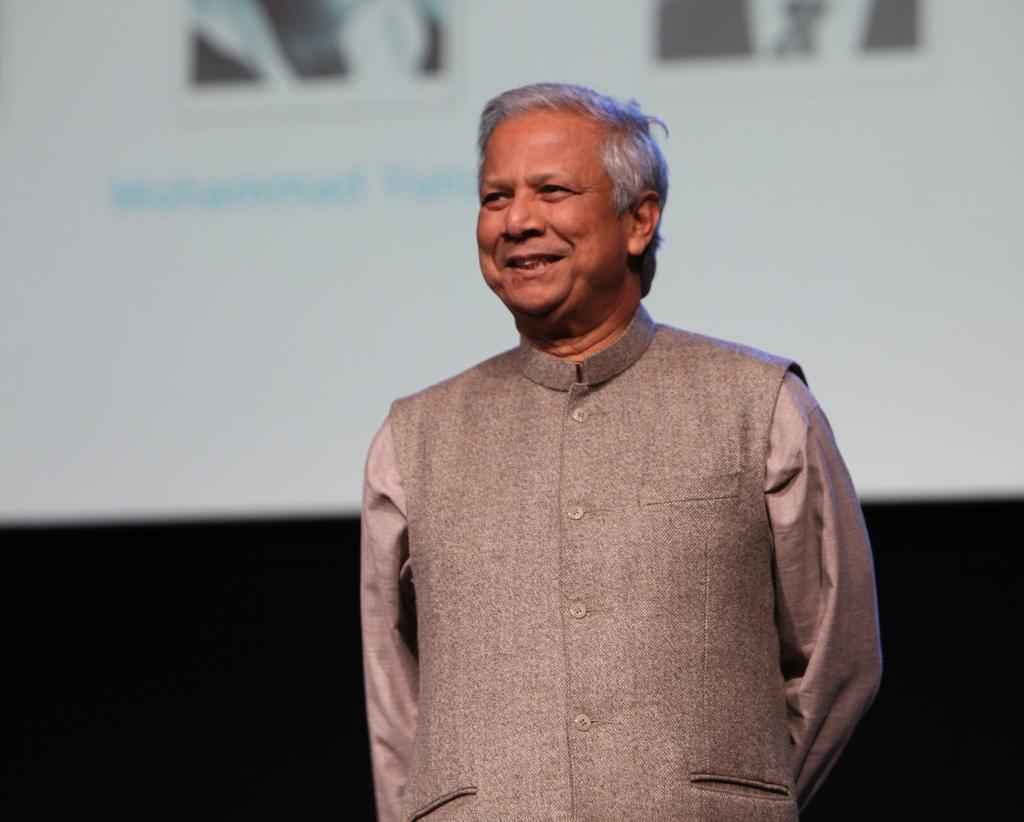What is the main subject of the image? There is a man in the image. Where is the man located in relation to the image? The man is standing in the foreground. What is the man's facial expression? The man is smiling. How is the background of the image depicted? The background of the man is blurred. Can you see any cords attached to the man's eye in the image? There are no cords attached to the man's eye in the image. 